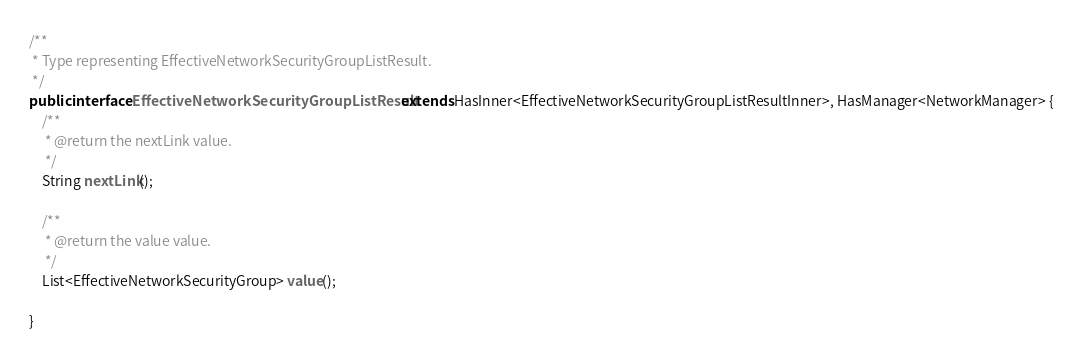<code> <loc_0><loc_0><loc_500><loc_500><_Java_>/**
 * Type representing EffectiveNetworkSecurityGroupListResult.
 */
public interface EffectiveNetworkSecurityGroupListResult extends HasInner<EffectiveNetworkSecurityGroupListResultInner>, HasManager<NetworkManager> {
    /**
     * @return the nextLink value.
     */
    String nextLink();

    /**
     * @return the value value.
     */
    List<EffectiveNetworkSecurityGroup> value();

}
</code> 